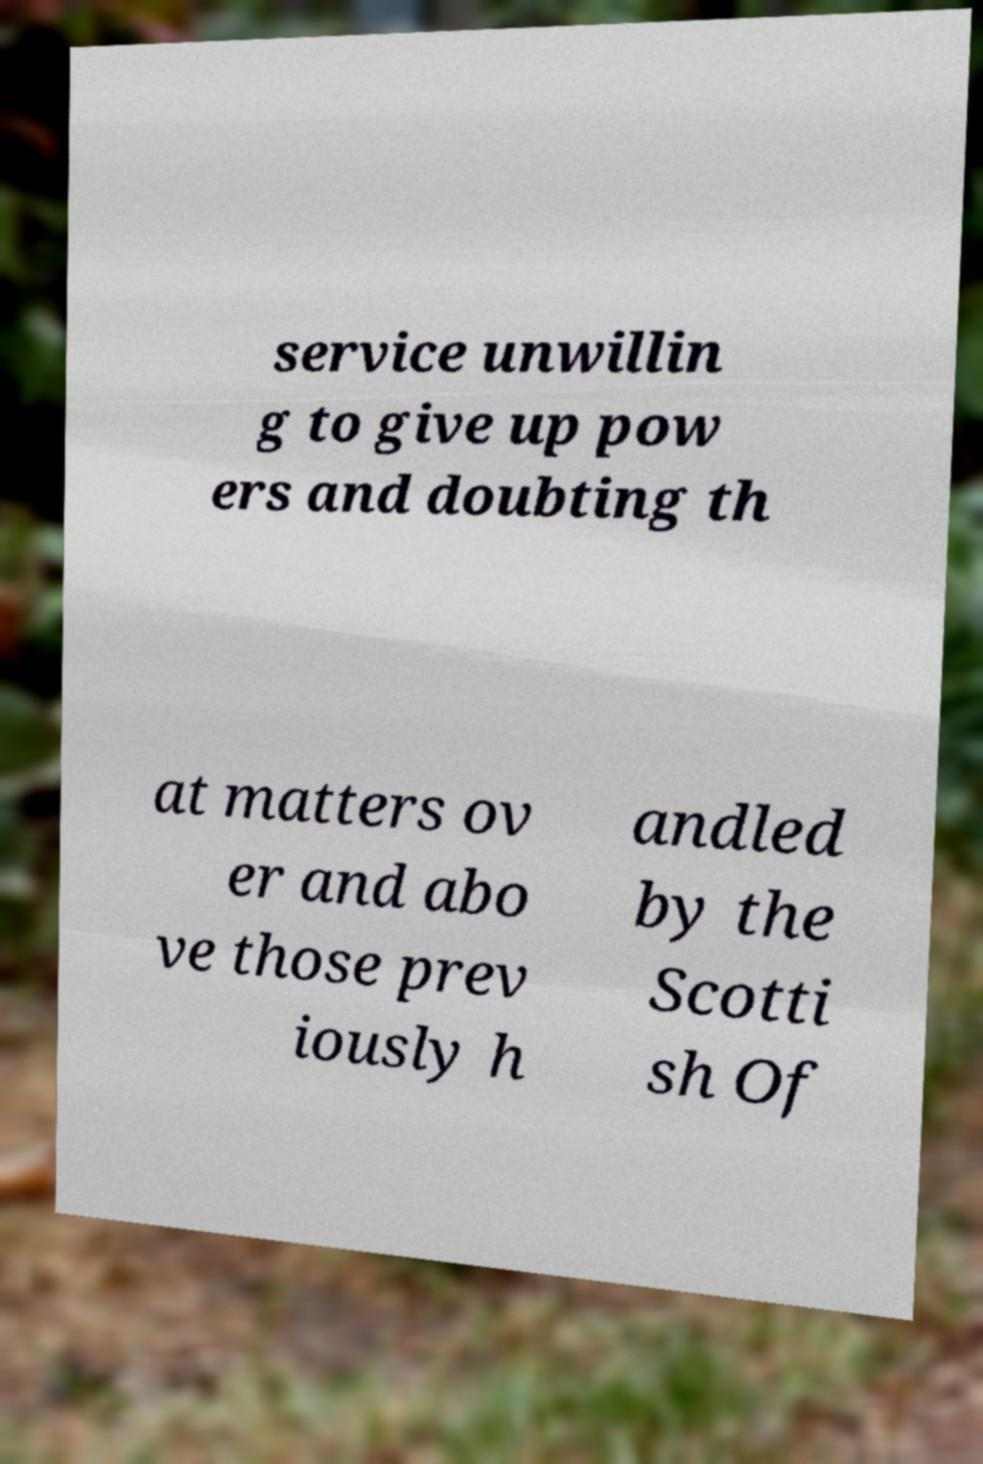I need the written content from this picture converted into text. Can you do that? service unwillin g to give up pow ers and doubting th at matters ov er and abo ve those prev iously h andled by the Scotti sh Of 